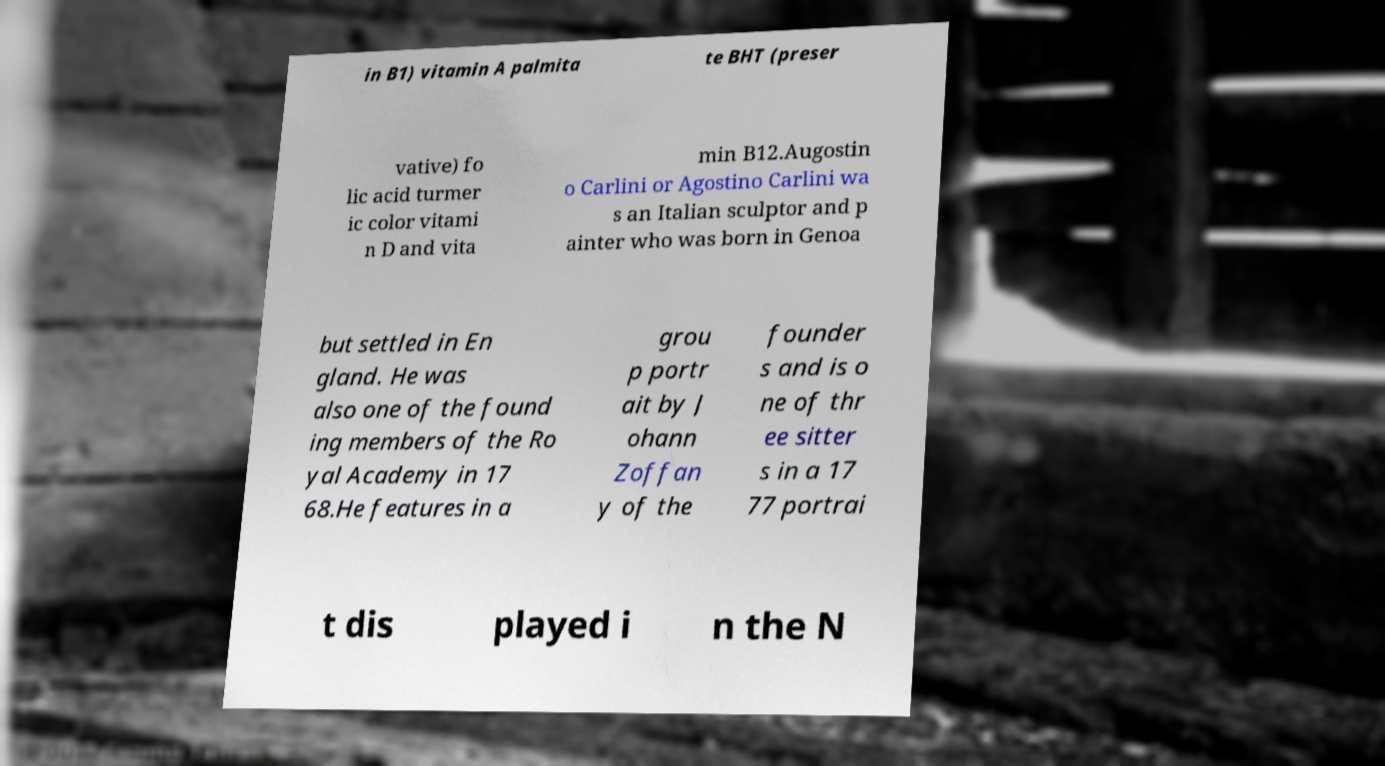For documentation purposes, I need the text within this image transcribed. Could you provide that? in B1) vitamin A palmita te BHT (preser vative) fo lic acid turmer ic color vitami n D and vita min B12.Augostin o Carlini or Agostino Carlini wa s an Italian sculptor and p ainter who was born in Genoa but settled in En gland. He was also one of the found ing members of the Ro yal Academy in 17 68.He features in a grou p portr ait by J ohann Zoffan y of the founder s and is o ne of thr ee sitter s in a 17 77 portrai t dis played i n the N 